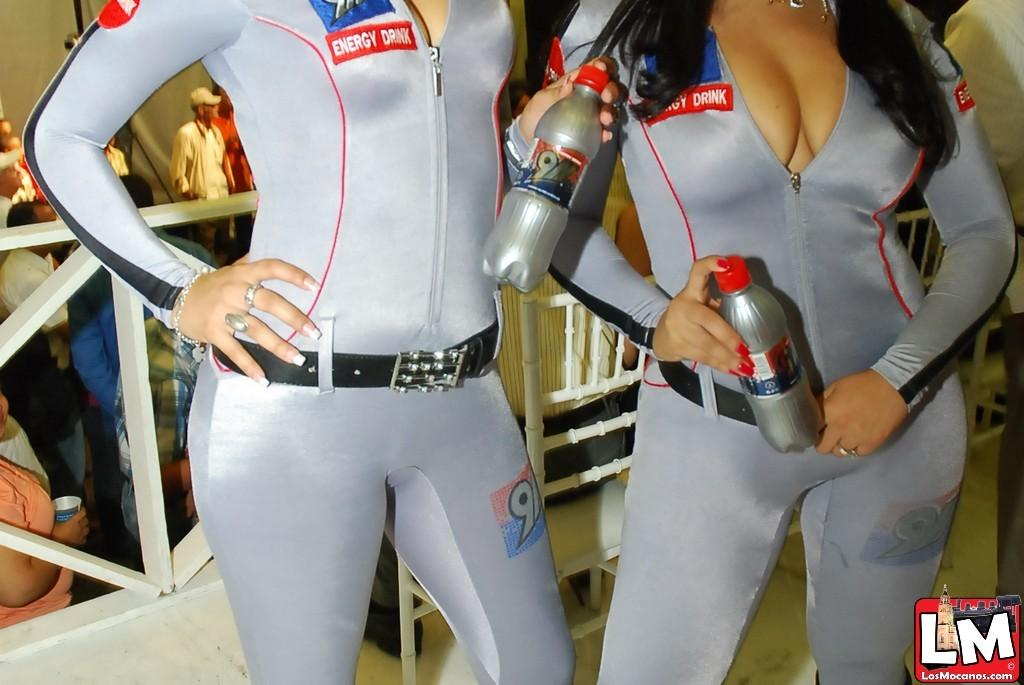<image>
Describe the image concisely. Two women wear tight, revealing silver body suits, with "Energy Drink" on the right side of their chests. 